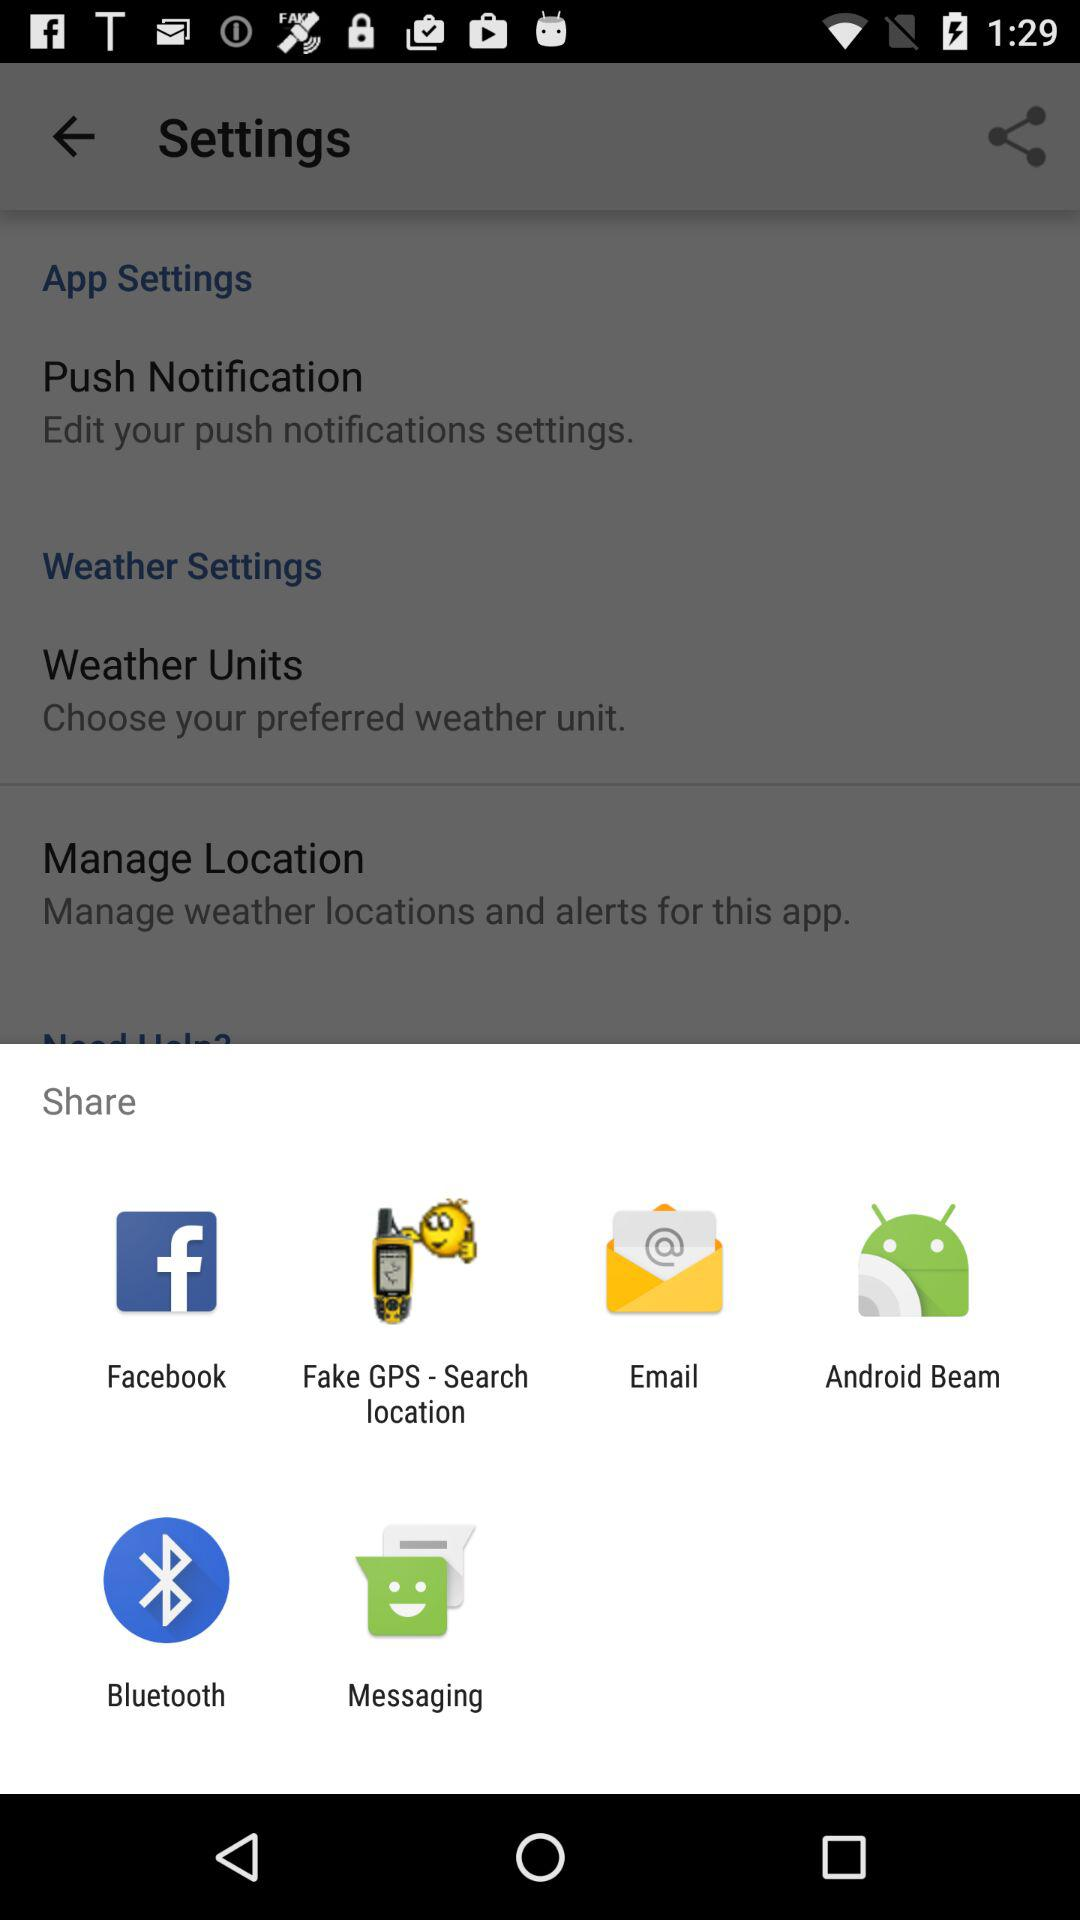Through which app can I share? You can share through "Facebook", "Fake GPS - Search location", "Email", "Android Beam", "Bluetooth" and "Messaging". 